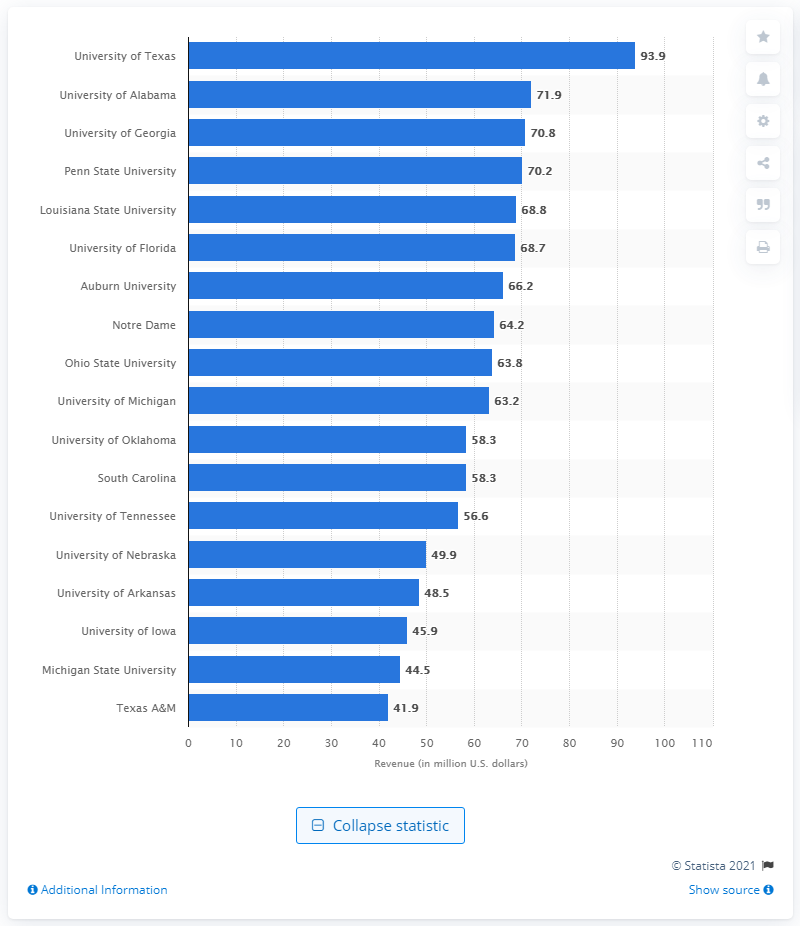How much revenue did the University of Michigan generate in 2011? According to the provided chart, the University of Michigan generated approximately $63.2 million in revenue. This visual data, likely sourced from Statista as indicated in the image, offers a comparison across various universities for that year. 